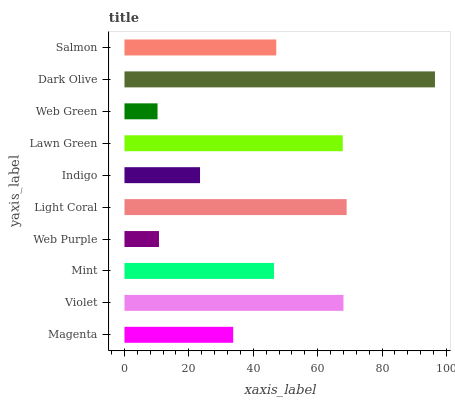Is Web Green the minimum?
Answer yes or no. Yes. Is Dark Olive the maximum?
Answer yes or no. Yes. Is Violet the minimum?
Answer yes or no. No. Is Violet the maximum?
Answer yes or no. No. Is Violet greater than Magenta?
Answer yes or no. Yes. Is Magenta less than Violet?
Answer yes or no. Yes. Is Magenta greater than Violet?
Answer yes or no. No. Is Violet less than Magenta?
Answer yes or no. No. Is Salmon the high median?
Answer yes or no. Yes. Is Mint the low median?
Answer yes or no. Yes. Is Magenta the high median?
Answer yes or no. No. Is Web Green the low median?
Answer yes or no. No. 